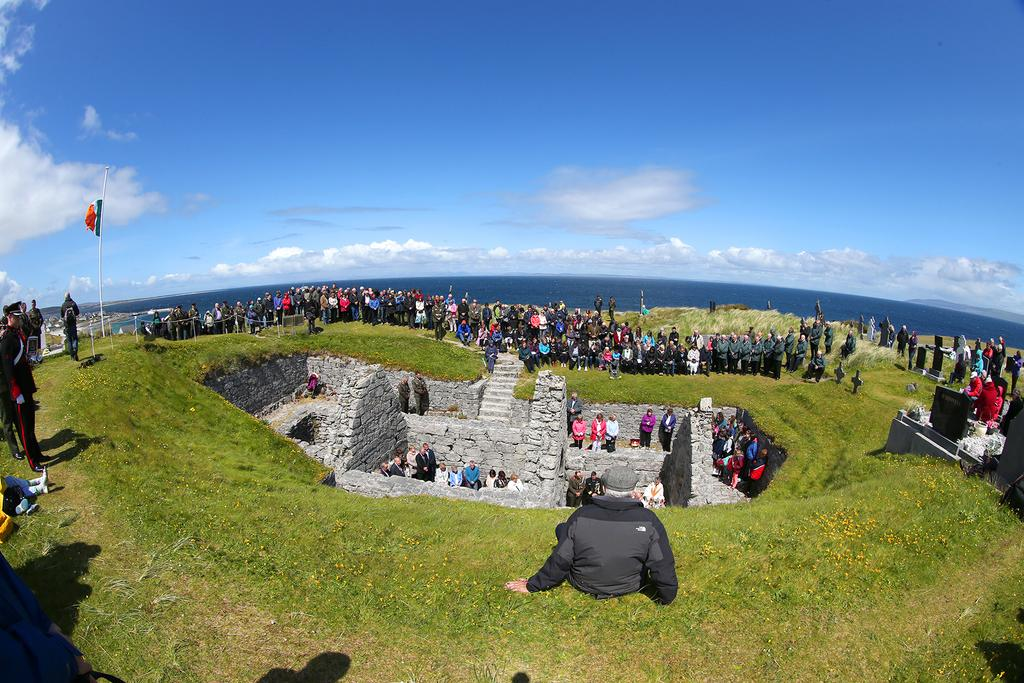What type of surface can be seen in the image? A: There is ground in the image. How many people are present in the image? There are many people standing in the image. What is one structure visible in the image? There is a wall in the image. What type of vegetation is present in the image? There is grass in the image. What is attached to the pole in the image? There is a flag on the pole in the image. What is another natural element visible in the image? There is water in the image. What is the condition of the sky in the image? The sky is clear in the image. What type of toys are being played with by the bears in the image? There are no bears or toys present in the image. What is the frame made of in the image? There is no frame present in the image. 